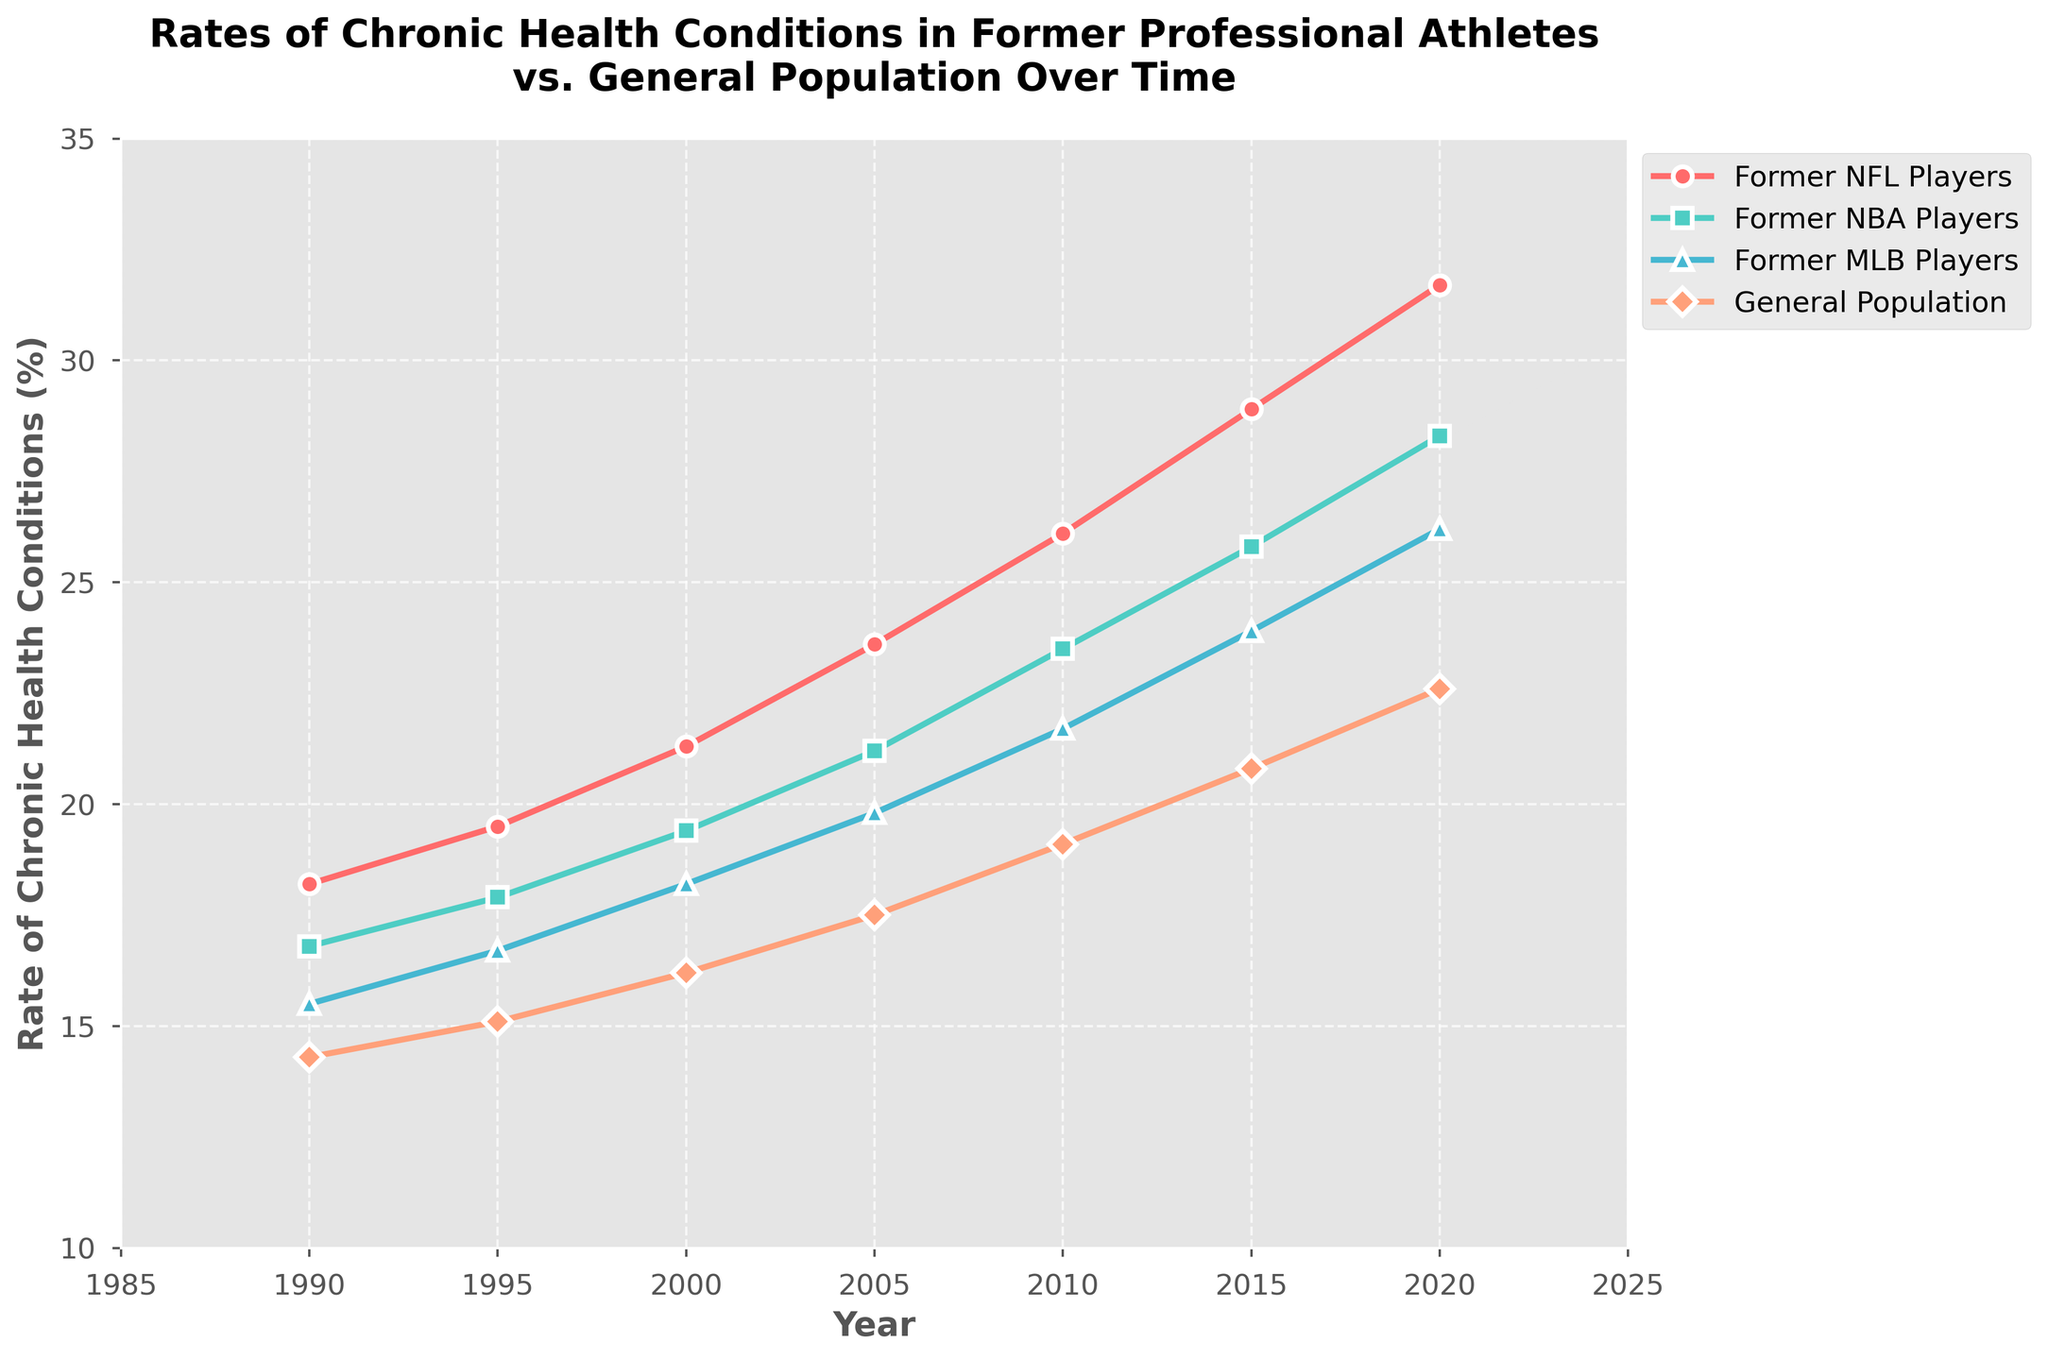What is the rate of chronic health conditions in former NFL players in 2005? Look at the point corresponding to 2005 on the line representing former NFL players. It is positioned slightly above the 23% mark.
Answer: 23.6% How does the rate of chronic health conditions in the general population change from 1990 to 2020? Find the rates of the general population in 1990 and 2020, and subtract the former from the latter. It increases from 14.3% to 22.6%.
Answer: 8.3% Among all categories, which group had the lowest rate of chronic health conditions in 2010? Check the 2010 rates of all groups and identify the lowest one. Former MLB Players had the lowest rate, at 21.7%.
Answer: Former MLB Players Which category shows the fastest increase in the rate of chronic health conditions over time? Look for the category with the steepest line slope. The line for former NFL players shows the fastest increase compared to the other groups.
Answer: Former NFL Players What is the average rate of chronic health conditions for former NBA players over the years shown? Add the rates of former NBA players for all the years and divide by the number of years (7). (16.8 + 17.9 + 19.4 + 21.2 + 23.5 + 25.8 + 28.3) / 7 = 21.27%
Answer: 21.27% How much higher is the rate of chronic health conditions in former NFL players compared to the general population in 2020? Find the rate in both groups for 2020 and subtract the latter from the former (31.7% - 22.6%).
Answer: 9.1% Which group had the largest increase in chronic health conditions from 2005 to 2015? Subtract the 2005 rate from the 2015 rate for each group and compare the differences. Former NFL Players had the largest increase from 23.6% to 28.9% (5.3%).
Answer: Former NFL Players In what year did former NFL players surpass a 25% rate of chronic health conditions? Identify the first year where the rate for former NFL players exceeds 25%. It surpasses 25% in 2010.
Answer: 2010 